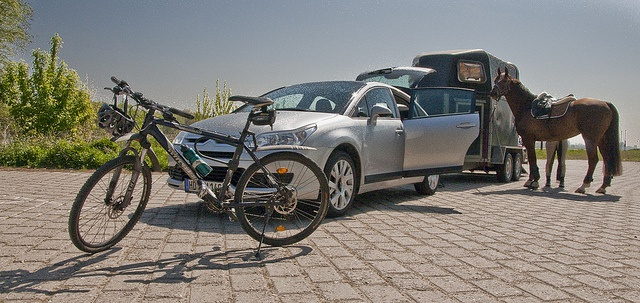Describe the objects in this image and their specific colors. I can see bicycle in olive, black, gray, and darkgray tones, car in olive, gray, black, darkgray, and lightgray tones, and horse in olive, black, gray, and darkgray tones in this image. 